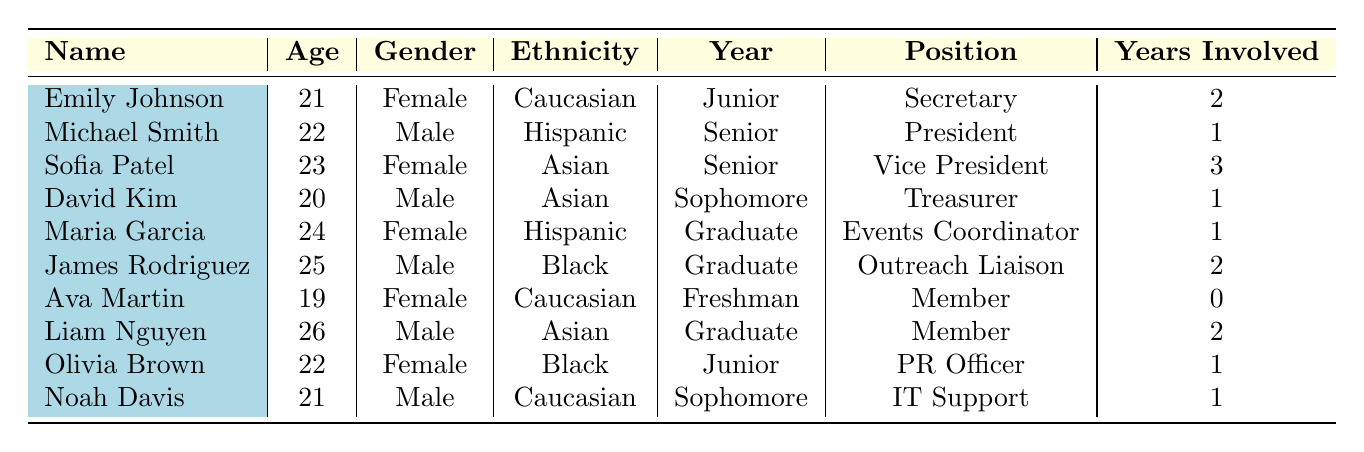What is the age of the youngest nursing student involved in student government? The youngest nursing student listed in the table is Ava Martin, who is 19 years old.
Answer: 19 How many nursing students are involved in student government? By counting the entries in the table, there are a total of 10 nursing students involved in student government.
Answer: 10 How many female nursing students hold a position in student government? There are 5 females listed: Emily Johnson (Secretary), Sofia Patel (Vice President), Maria Garcia (Events Coordinator), Olivia Brown (Public Relations Officer), and Ava Martin (Member).
Answer: 5 What is the average age of the nursing students involved in student government? To find the average, sum their ages (21 + 22 + 23 + 20 + 24 + 25 + 19 + 26 + 22 + 21 =  211), and then divide by the total number of students (211 / 10 = 21.1). The average age is 21.1 years.
Answer: 21.1 Is Sofia Patel the only senior nursing student involved in student government? Checking the table, both Sofia Patel and Michael Smith are seniors; therefore, Sofia Patel is not the only one.
Answer: No How many students have been involved in student government for more than one year? The students with more than one year of involvement are Emily Johnson (2 years), Sofia Patel (3 years), James Rodriguez (2 years), and Liam Nguyen (2 years), totaling 4 students.
Answer: 4 What positions do males occupy in the student government? The males listed in the table hold the following positions: Michael Smith (President), David Kim (Treasurer), James Rodriguez (Outreach Liaison), and Liam Nguyen (Member).
Answer: President, Treasurer, Outreach Liaison, Member Which ethnic group is represented the most among students involved in student government? By comparing the entries, Caucasian appears 3 times (Emily Johnson, Ava Martin, Noah Davis), Hispanic is present 2 times (Michael Smith, Maria Garcia), Asian is also present 3 times (Sofia Patel, David Kim, Liam Nguyen), and Black appears 2 times (James Rodriguez, Olivia Brown). Therefore, Caucasian and Asian both represent the most at 3.
Answer: Caucasian and Asian What is the position of the nursing student who has been involved the longest? Sofia Patel has been involved the longest with 3 years and she is the Vice President.
Answer: Vice President 